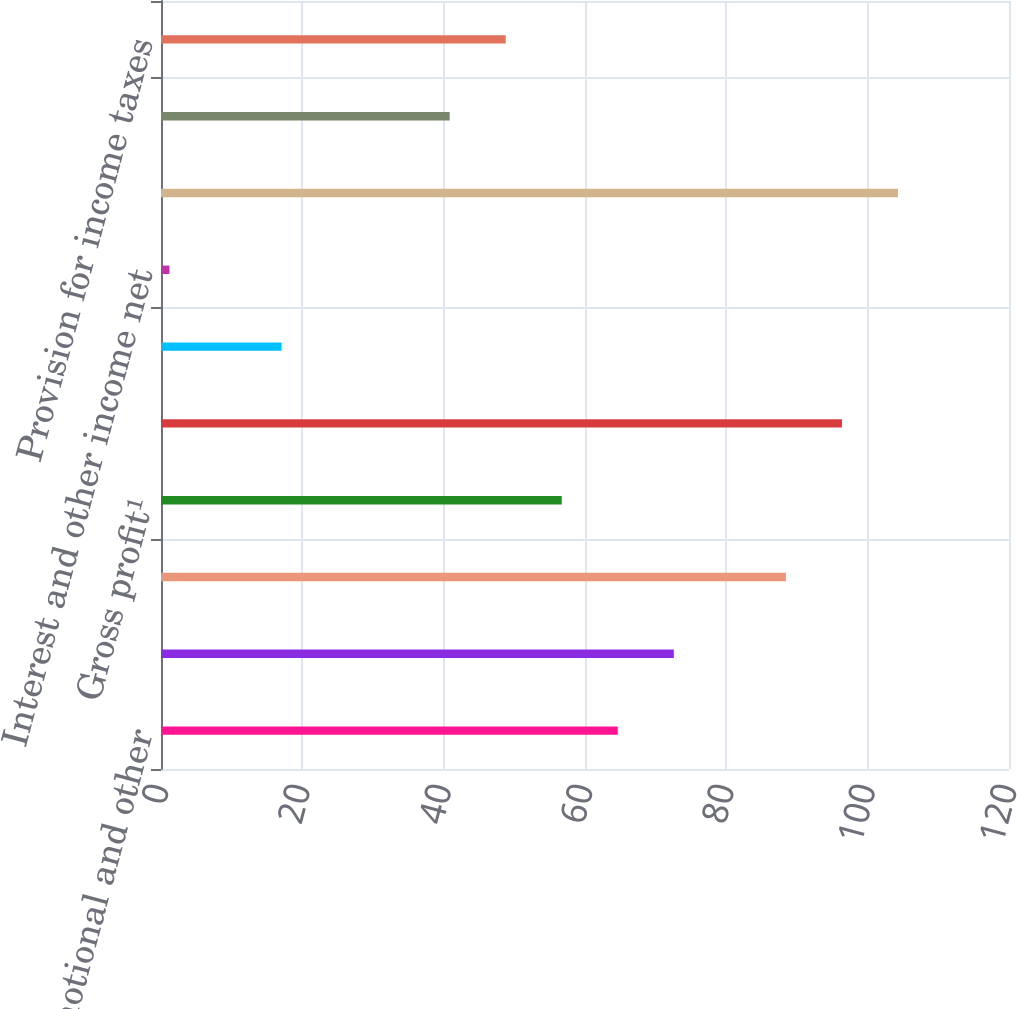<chart> <loc_0><loc_0><loc_500><loc_500><bar_chart><fcel>Less Promotional and other<fcel>Net sales¹<fcel>Cost of sales<fcel>Gross profit¹<fcel>Operating expenses ^2<fcel>Operating income ^12<fcel>Interest and other income net<fcel>Loss on investments and put<fcel>Income before provision for<fcel>Provision for income taxes<nl><fcel>64.64<fcel>72.57<fcel>88.43<fcel>56.71<fcel>96.36<fcel>17.06<fcel>1.2<fcel>104.29<fcel>40.85<fcel>48.78<nl></chart> 